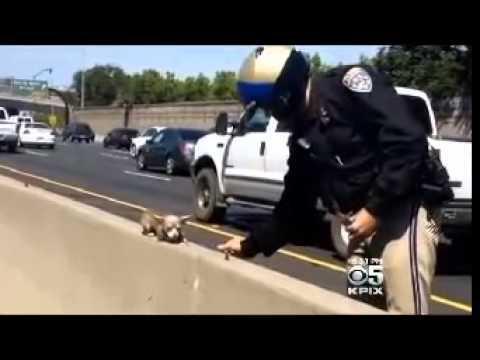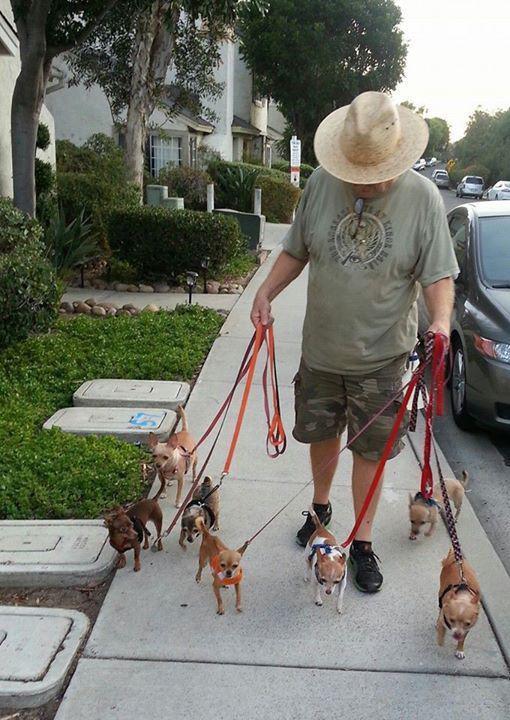The first image is the image on the left, the second image is the image on the right. For the images displayed, is the sentence "In one image, seven small dogs and a large gray and white cat are in a shady grassy yard area with trees and shrubs." factually correct? Answer yes or no. No. The first image is the image on the left, the second image is the image on the right. For the images shown, is this caption "The group of dogs in one of the images is standing on the grass." true? Answer yes or no. No. 